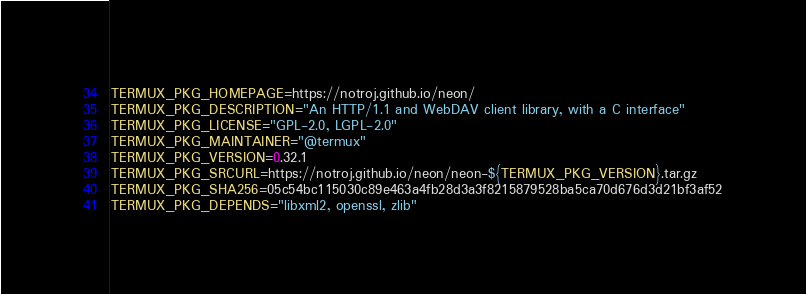<code> <loc_0><loc_0><loc_500><loc_500><_Bash_>TERMUX_PKG_HOMEPAGE=https://notroj.github.io/neon/
TERMUX_PKG_DESCRIPTION="An HTTP/1.1 and WebDAV client library, with a C interface"
TERMUX_PKG_LICENSE="GPL-2.0, LGPL-2.0"
TERMUX_PKG_MAINTAINER="@termux"
TERMUX_PKG_VERSION=0.32.1
TERMUX_PKG_SRCURL=https://notroj.github.io/neon/neon-${TERMUX_PKG_VERSION}.tar.gz
TERMUX_PKG_SHA256=05c54bc115030c89e463a4fb28d3a3f8215879528ba5ca70d676d3d21bf3af52
TERMUX_PKG_DEPENDS="libxml2, openssl, zlib"
</code> 